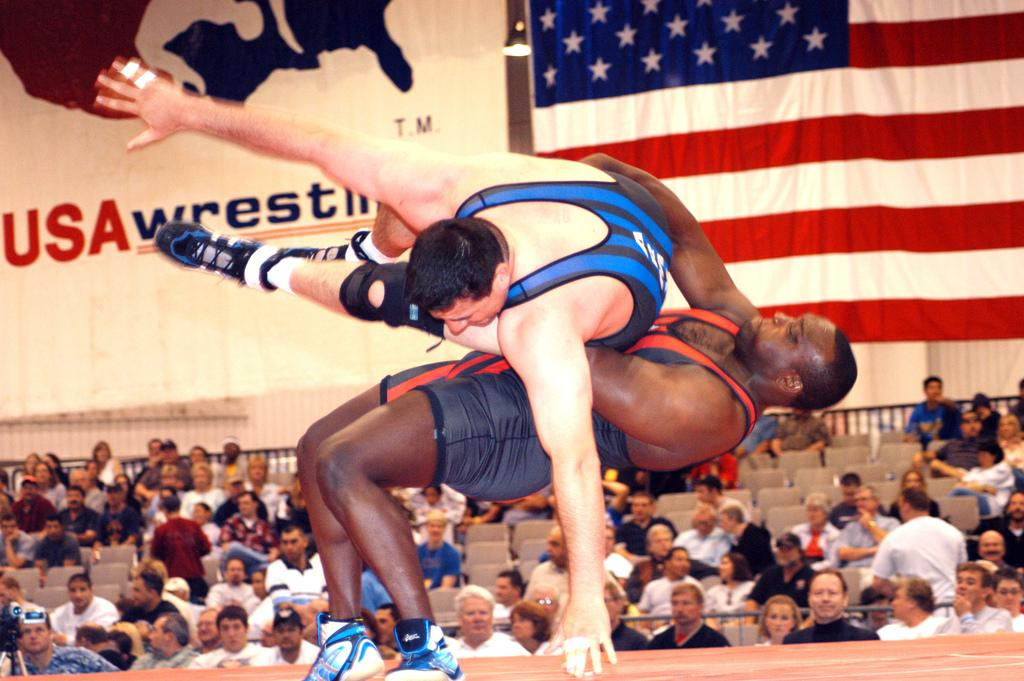<image>
Write a terse but informative summary of the picture. Two wrestlers are competing in a match with a sign that says USA Wrestling on the wall behind them. 